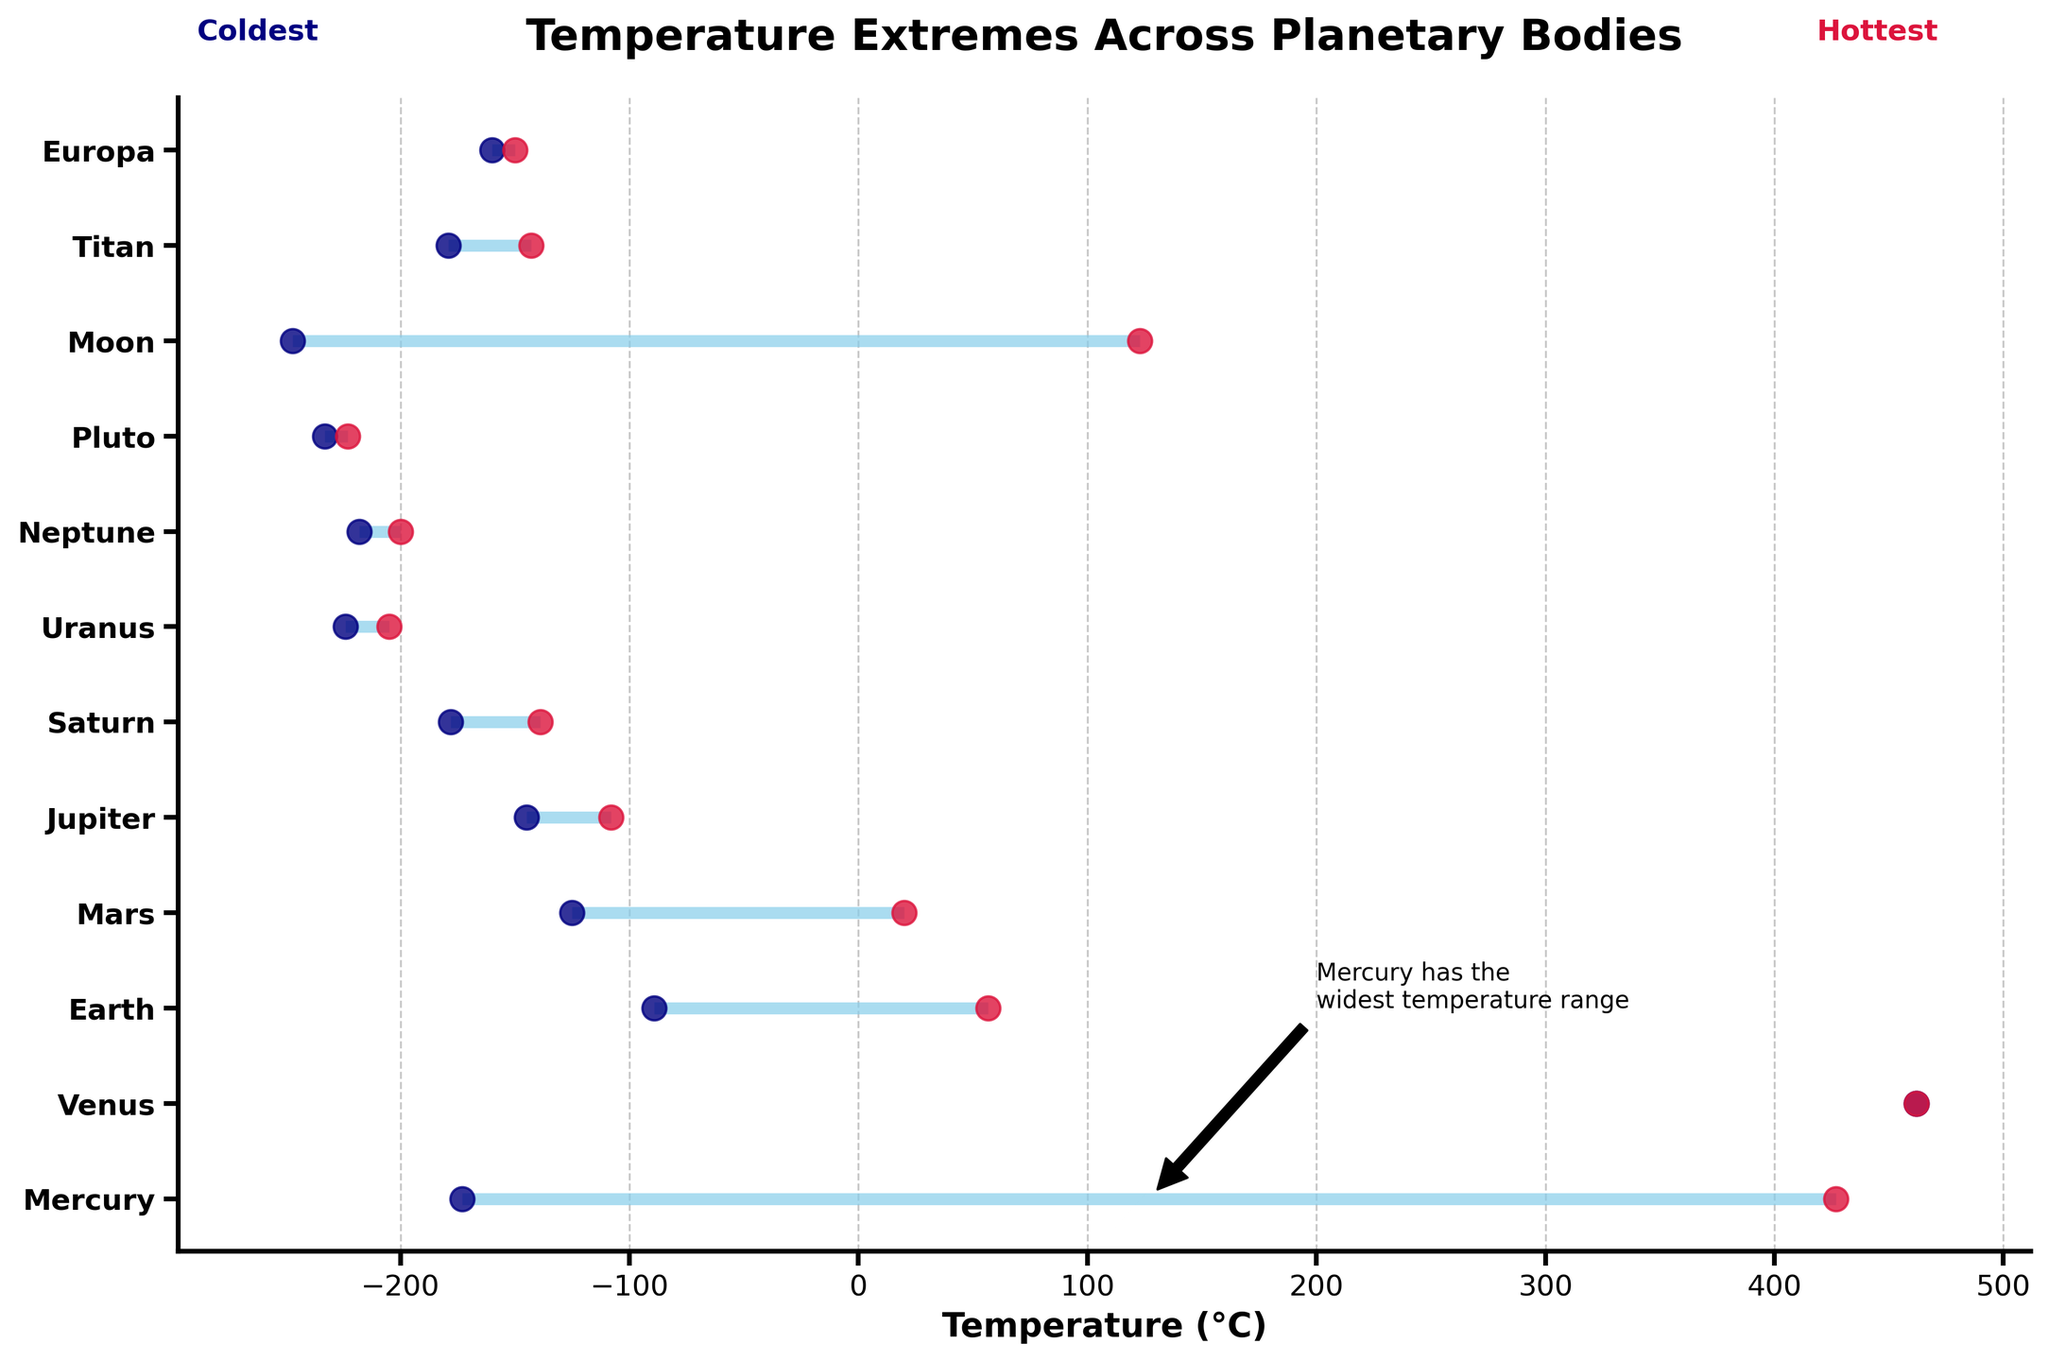Which planetary body has the widest temperature range? First, identify the planetary body with the highest difference between minimum and maximum temperatures. From the plot, Mercury's range (-173°C to 427°C) is the widest, as indicated by the annotation in the plot.
Answer: Mercury What's the minimum and maximum temperature on Venus? Spot Venus on the y-axis. Since Venus has a single mark for both minimum and maximum temperatures at 462°C, the temperatures are equal.
Answer: 462°C Which planetary body has the coldest minimum temperature? Locate the lowest temperature point plotted along the x-axis. Pluto has the coldest minimum temperature at -233°C.
Answer: Pluto How many planetary bodies have a minimum temperature below -200°C? Identify the planetary bodies with minimum temperatures below -200°C (Uranus, Neptune, Pluto, Moon). There are 4.
Answer: 4 What's the average maximum temperature of Earth, Mars, and Europa? Add the maximum temperatures: Earth (56.7°C), Mars (20°C), and Europa (-150°C). The sum is 56.7 + 20 + (-150) = -73.3. Divide by 3: -73.3/3 = -24.43.
Answer: -24.43°C Which planetary body has the smallest temperature range? Compare the temperature ranges for all planetary bodies. Venus has a temperature range of 0°C, as its minimum and maximum temperatures are the same (462°C).
Answer: Venus Is the maximum temperature on Titan hotter or colder than the maximum on Saturn? Check the temperatures: Titan's maximum is -143°C, and Saturn's maximum is -139°C. -143°C is lower than -139°C, so Titan is colder.
Answer: Colder Which planetary bodies have negative maximum temperatures? Identify those with maximum temperatures below 0°C: Jupiter, Saturn, Uranus, Neptune, Pluto, Titan, Europa. There are 7.
Answer: 7 What is the range of temperatures for Mars? Mars' minimum temperature is -125°C, and its maximum is 20°C. The range is 20 - (-125) = 145°C.
Answer: 145°C Which planetary body has the highest maximum temperature? Locate the highest mark on the maximum temperature scale. Mercury's maximum temperature is 427°C.
Answer: Mercury 